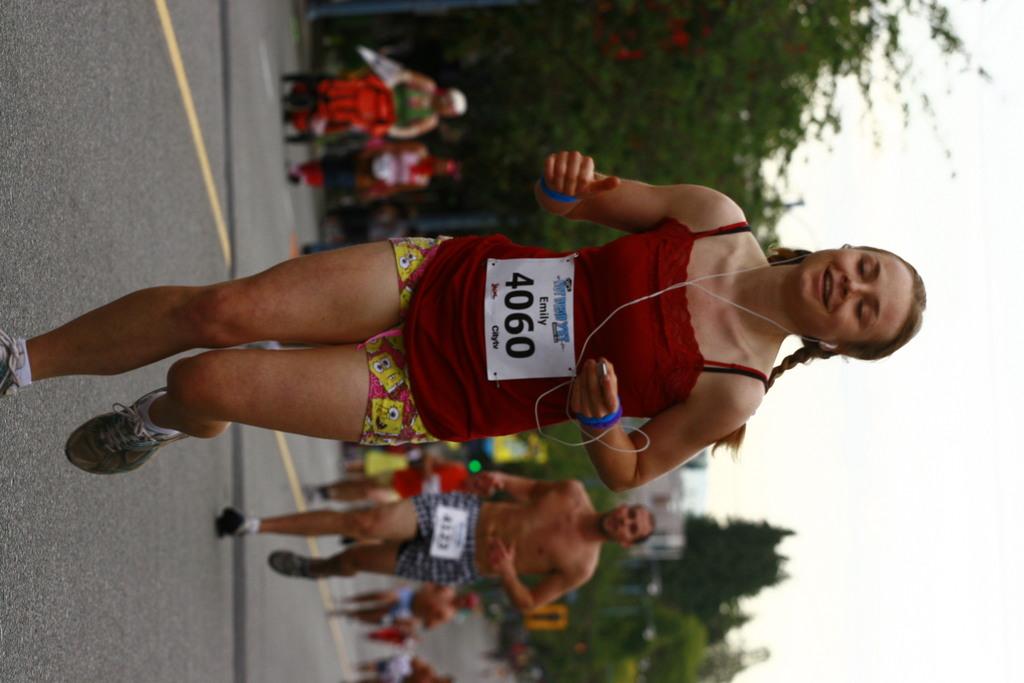What is the runners name?
Offer a very short reply. Emily. 